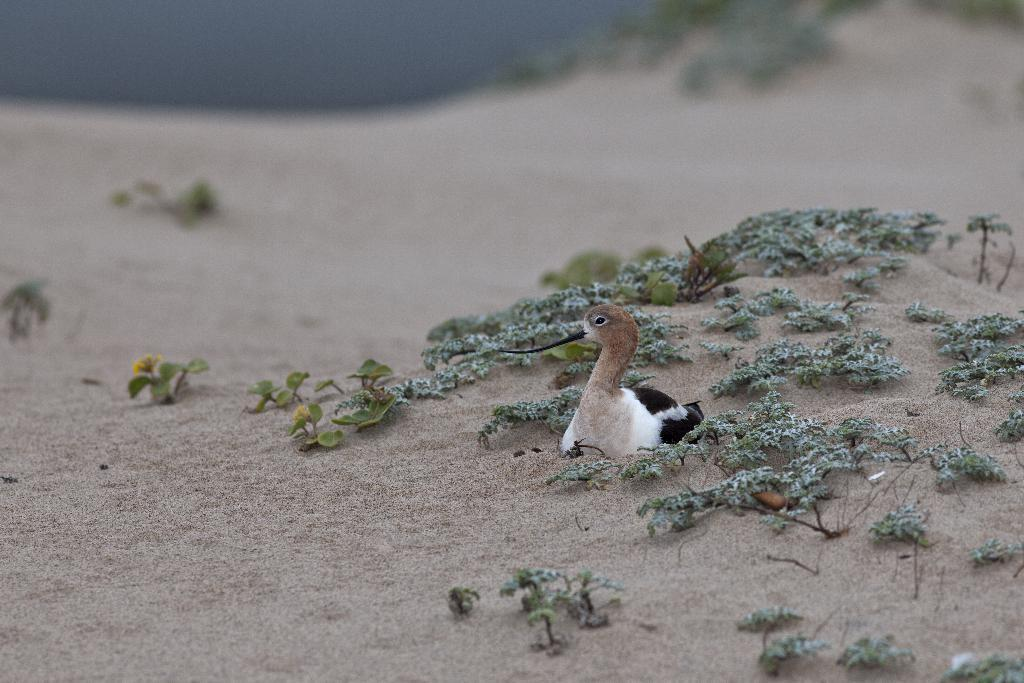What type of animal is in the image? There is a bird in the image. Where is the bird located? The bird is sitting on the sand. What type of vegetation can be seen in the image? There is grass visible in the image. What is visible at the top of the image? The sky is visible at the top of the image. Can you tell me how many bikes are parked next to the bird in the image? There are no bikes present in the image; it features a bird sitting on the sand. What type of process is being carried out by the bird in the image? There is no process being carried out by the bird in the image; it is simply sitting on the sand. 